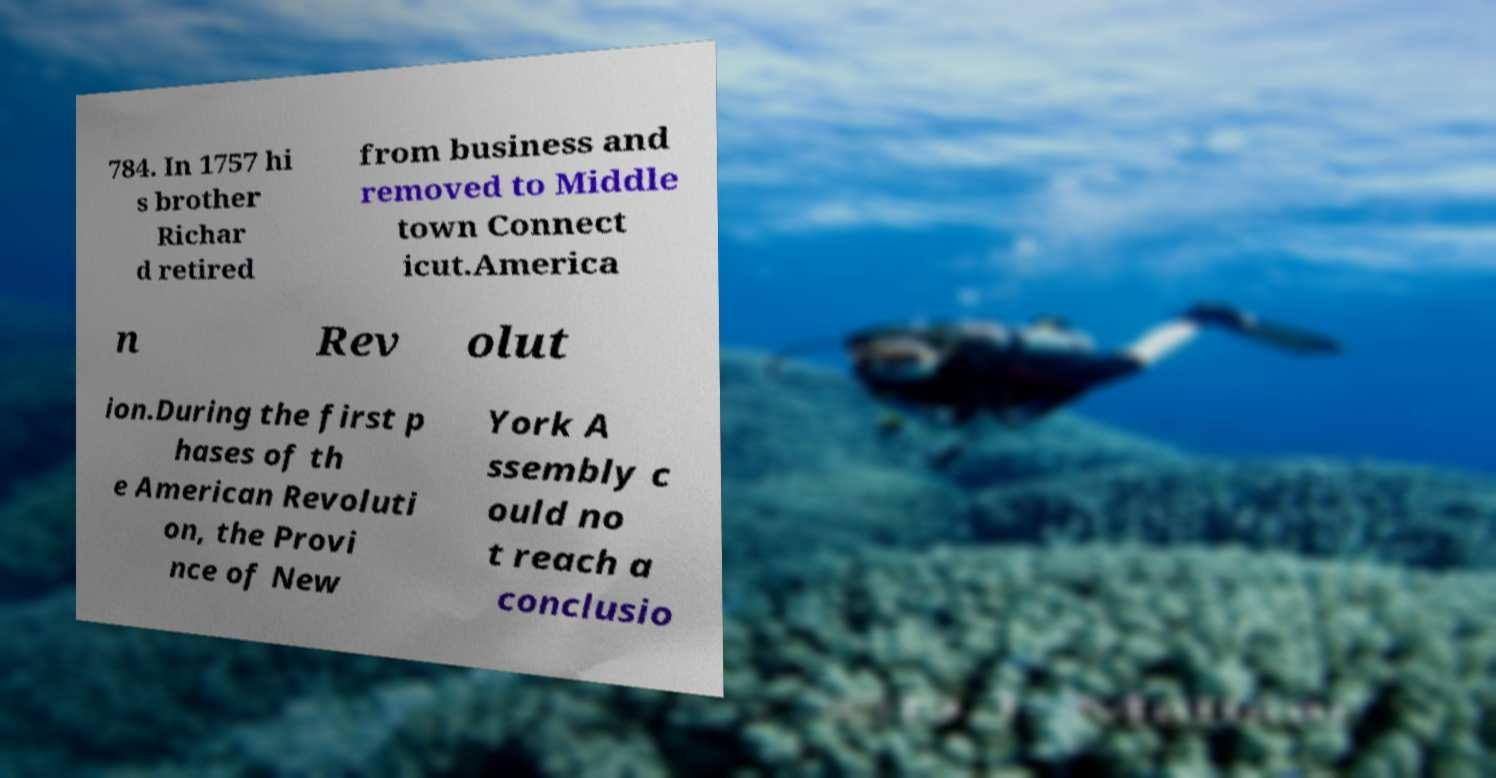Could you extract and type out the text from this image? 784. In 1757 hi s brother Richar d retired from business and removed to Middle town Connect icut.America n Rev olut ion.During the first p hases of th e American Revoluti on, the Provi nce of New York A ssembly c ould no t reach a conclusio 